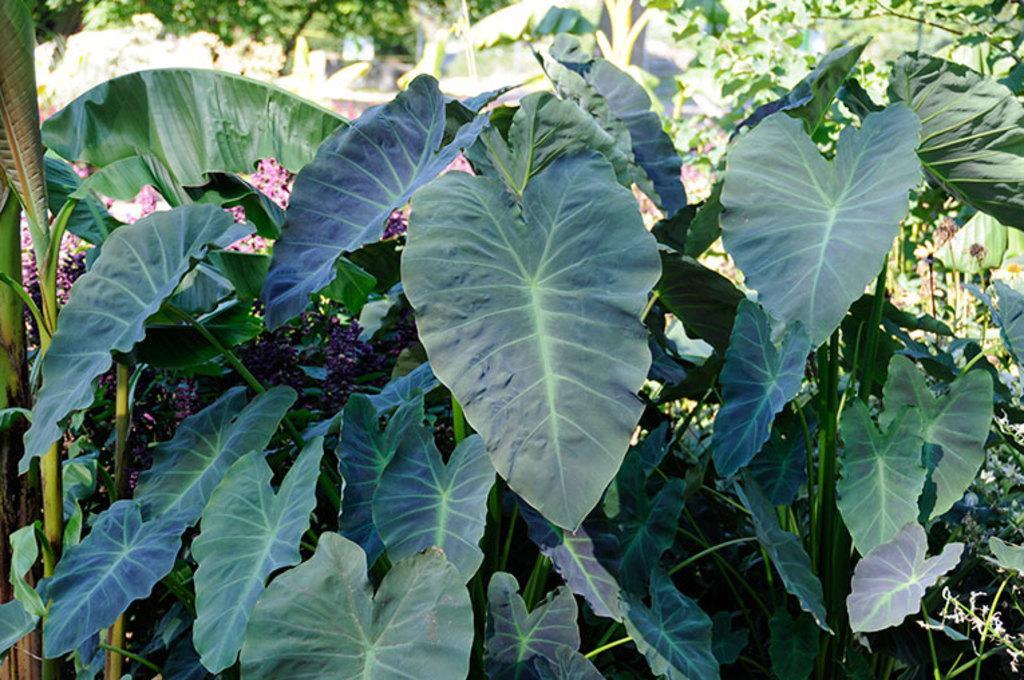Could you give a brief overview of what you see in this image? In this image there are many plants. 